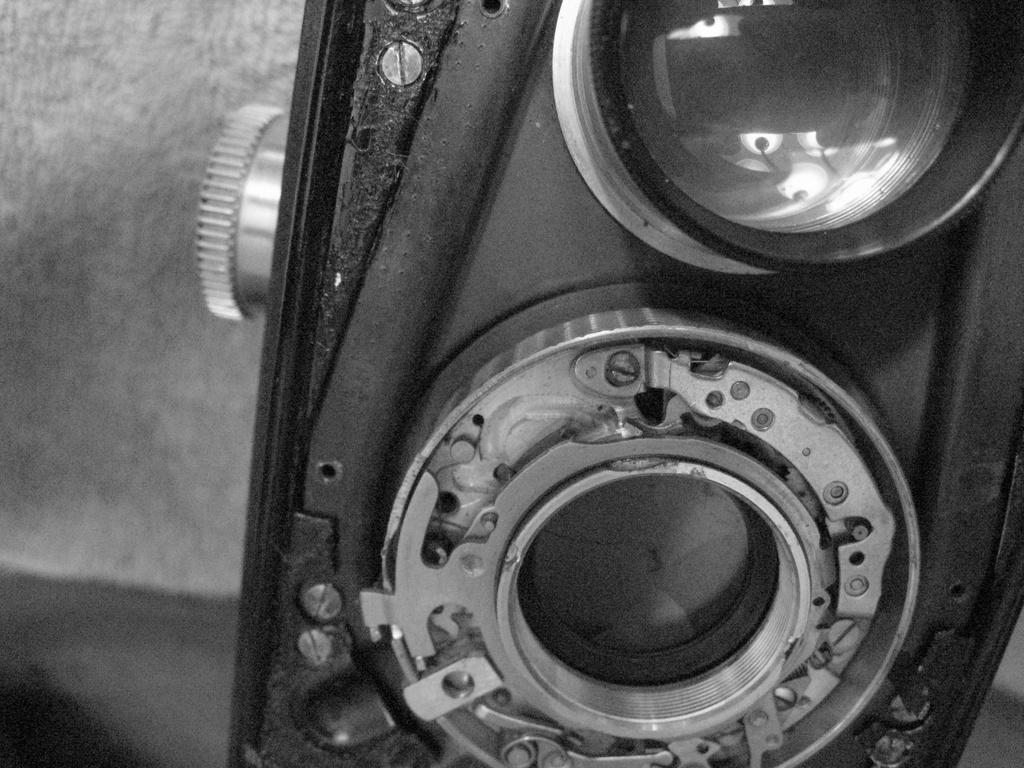Describe this image in one or two sentences. This is a black and white picture. In this picture, we can see an old camera with lens. On the left side of the image, there is a blurred view. 